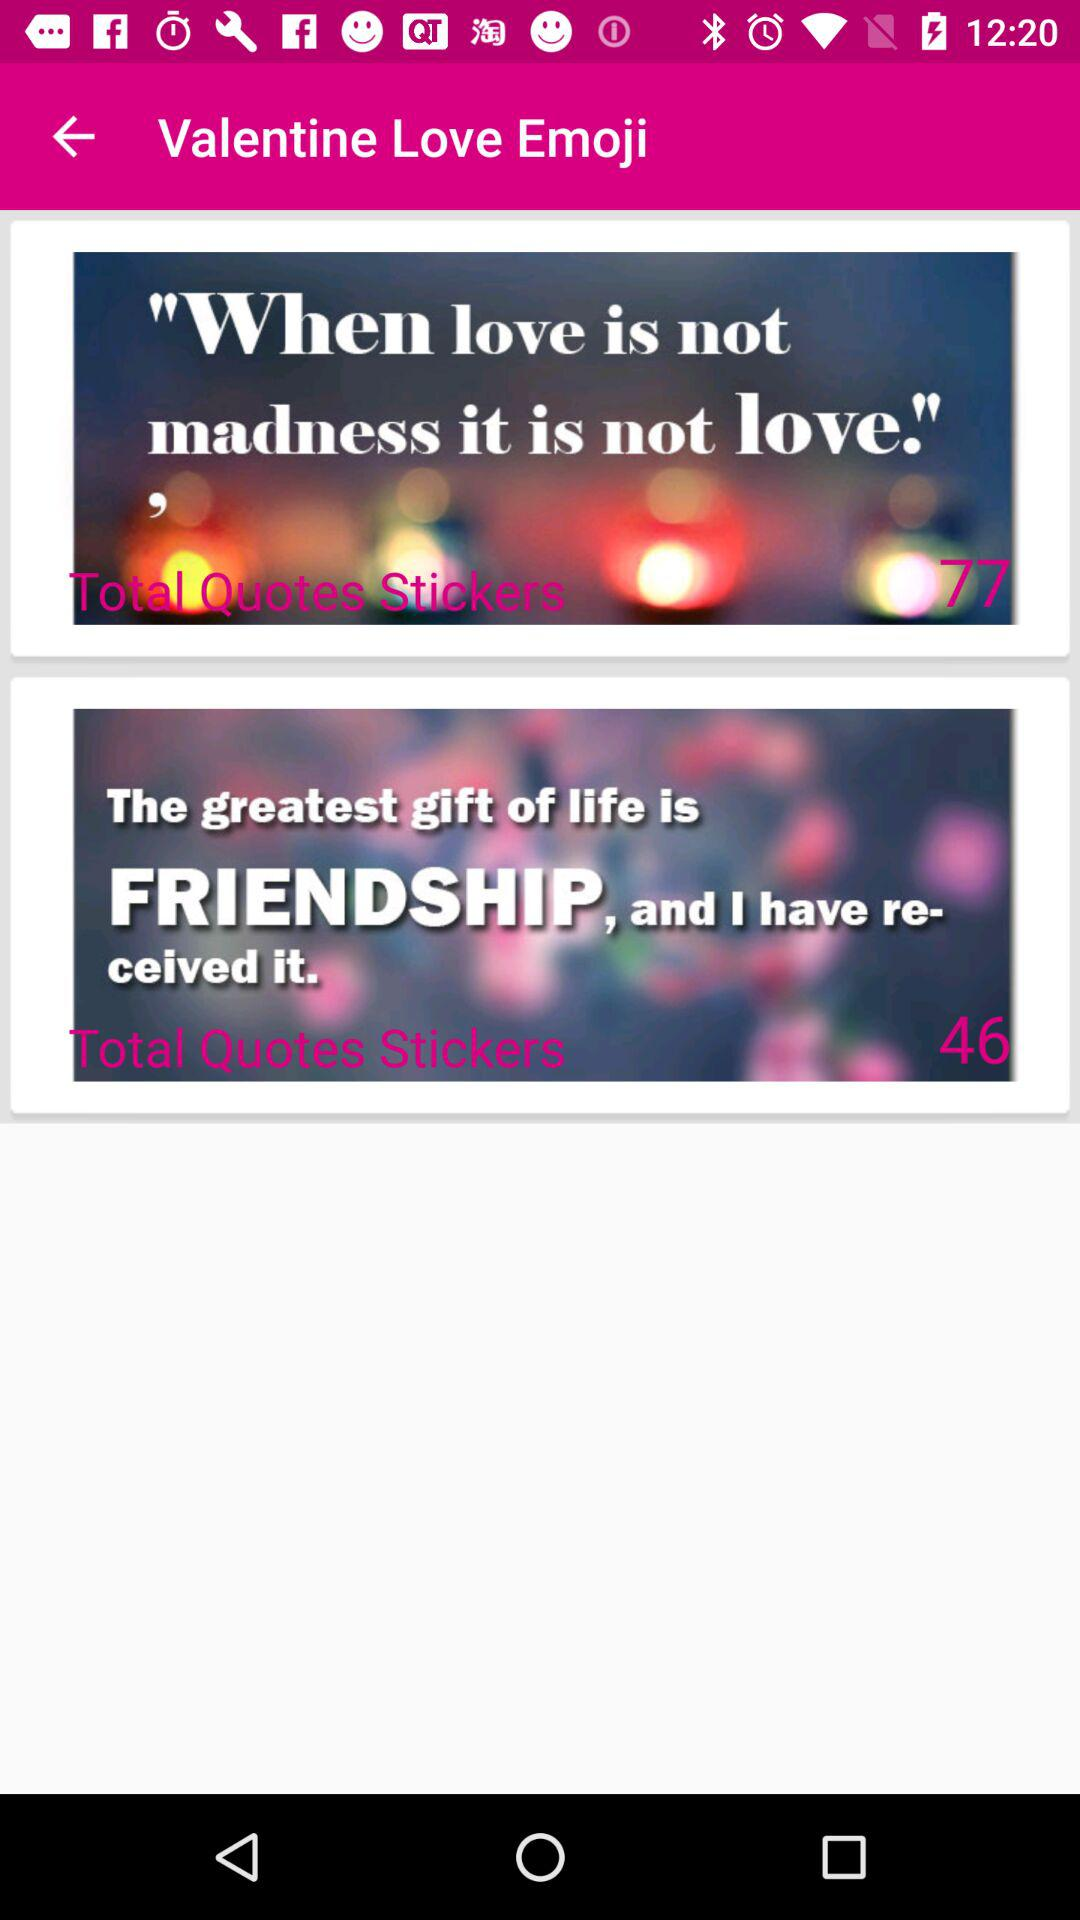What is the total number of quotes on friendship?
When the provided information is insufficient, respond with <no answer>. <no answer> 